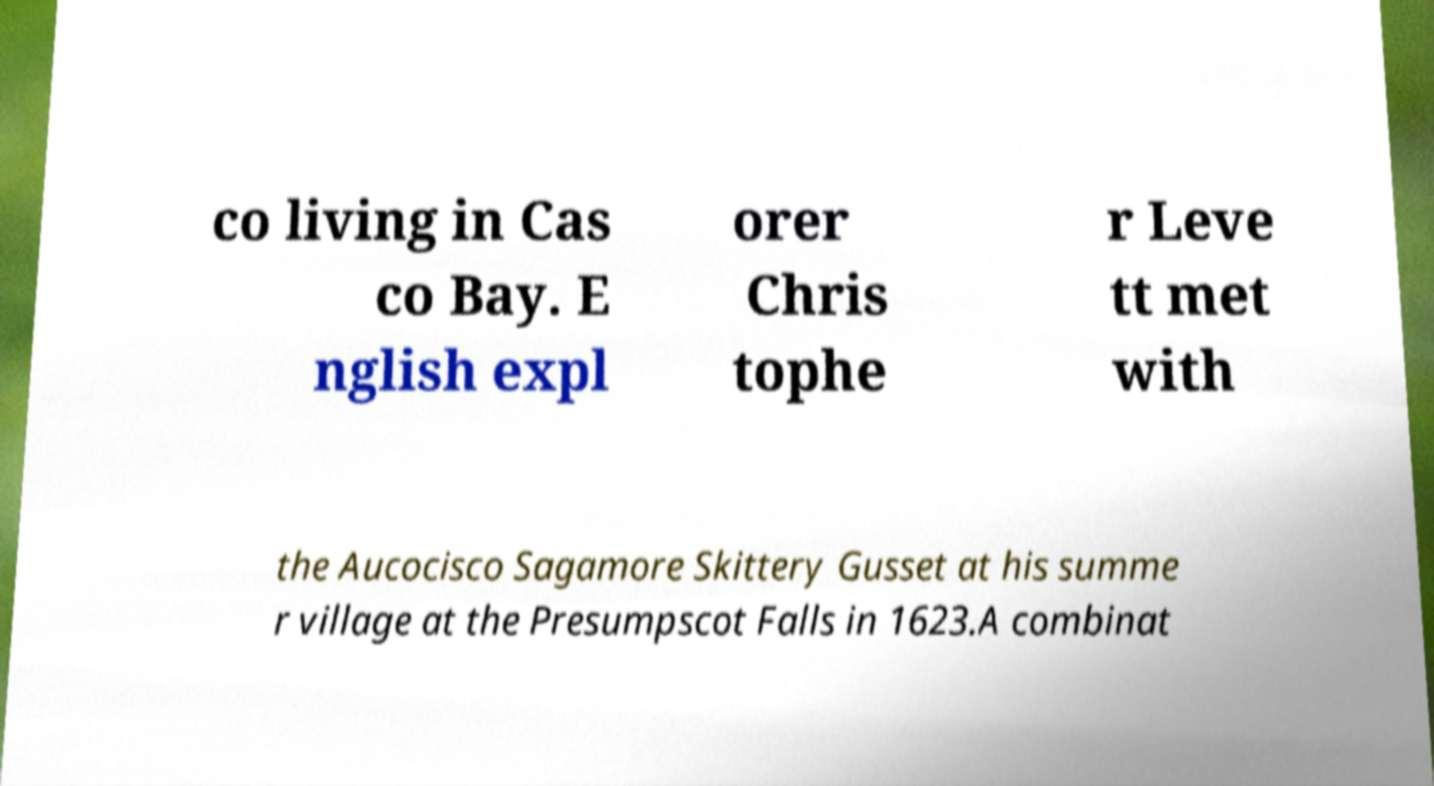Could you extract and type out the text from this image? co living in Cas co Bay. E nglish expl orer Chris tophe r Leve tt met with the Aucocisco Sagamore Skittery Gusset at his summe r village at the Presumpscot Falls in 1623.A combinat 